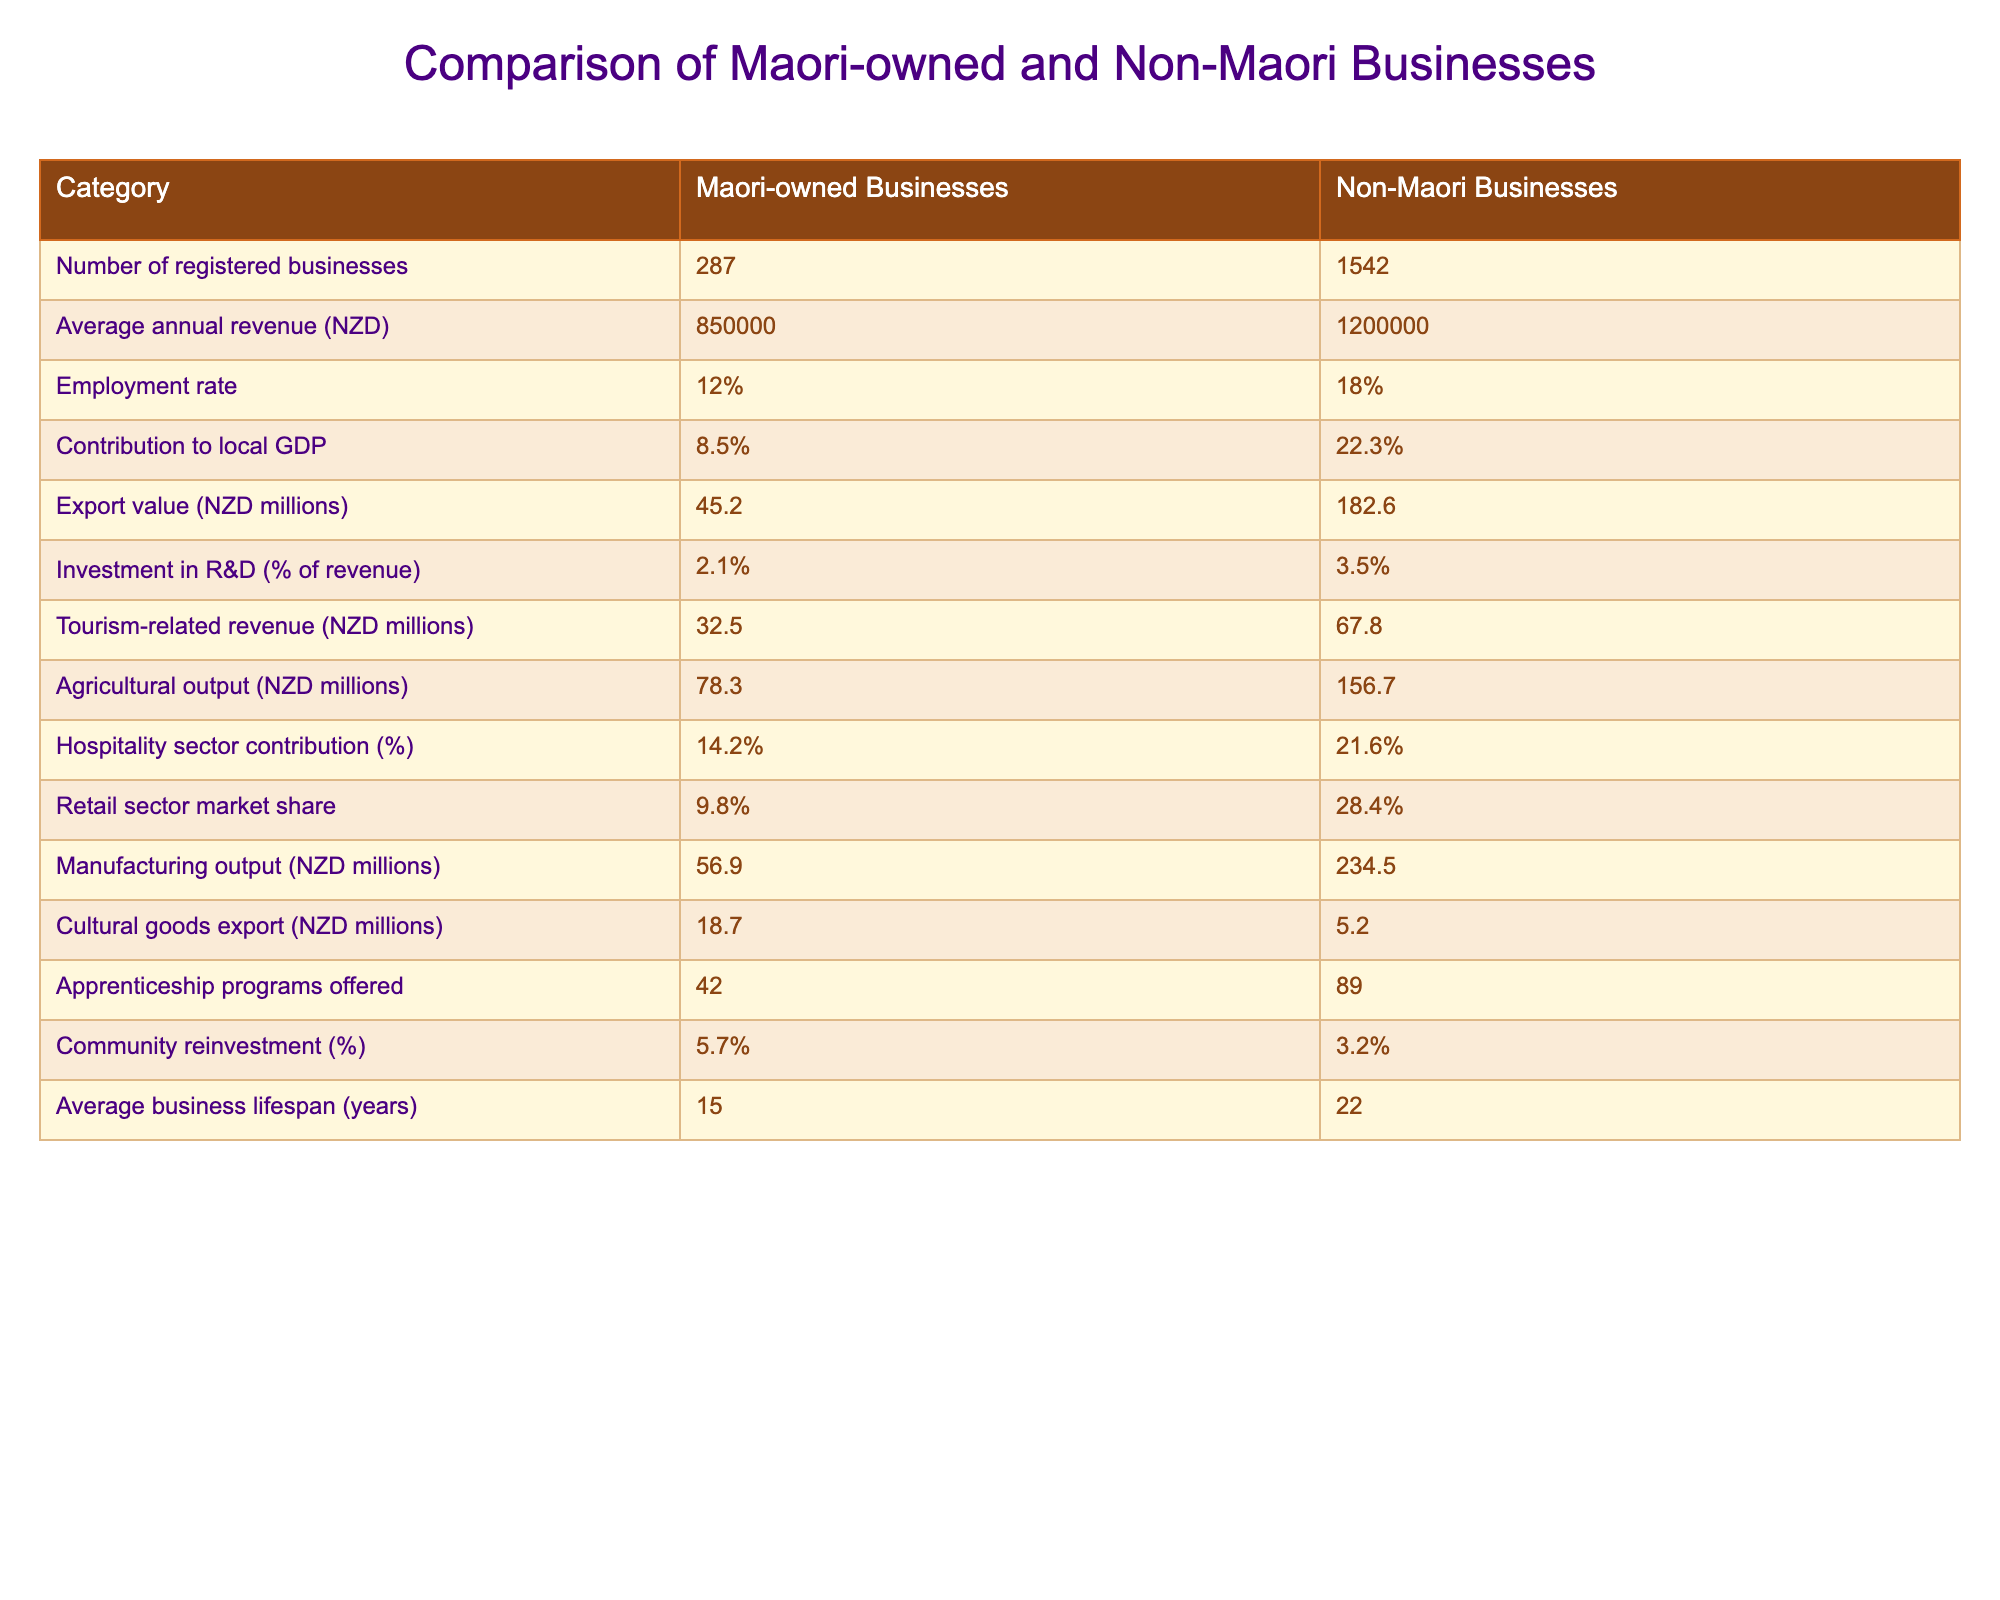What is the average annual revenue for Maori-owned businesses? According to the table, the average annual revenue for Maori-owned businesses is listed as 850000 NZD.
Answer: 850000 NZD What percentage of Maori-owned businesses contribute to the local GDP? The table shows that Maori-owned businesses contribute 8.5% to the local GDP.
Answer: 8.5% How much higher is the export value of non-Maori businesses compared to Maori-owned businesses? The export value for non-Maori businesses is 182.6 million NZD and for Maori-owned businesses, it is 45.2 million NZD. The difference is 182.6 - 45.2 = 137.4 million NZD.
Answer: 137.4 million NZD Do Maori-owned businesses have a higher community reinvestment percentage than non-Maori businesses? The community reinvestment percentage for Maori-owned businesses is 5.7% while for non-Maori businesses it is 3.2%. Since 5.7% is greater than 3.2%, the statement is true.
Answer: Yes What is the combined total of tourism-related revenue from both Maori and non-Maori businesses? The tourism-related revenue for Maori-owned businesses is 32.5 million NZD and for non-Maori businesses, it is 67.8 million NZD. The combined total is 32.5 + 67.8 = 100.3 million NZD.
Answer: 100.3 million NZD Which type of business has a longer average lifespan and what are the respective figures? From the table, non-Maori businesses have an average lifespan of 22 years while Maori-owned businesses have an average lifespan of 15 years. Thus, non-Maori businesses have a longer lifespan.
Answer: Non-Maori businesses, 22 years What is the difference in the number of registered businesses between Maori-owned and non-Maori businesses? The number of registered businesses for Maori-owned is 287 and for non-Maori is 1542. The difference is 1542 - 287 = 1255 registered businesses.
Answer: 1255 registered businesses Are Maori-owned businesses more involved in cultural goods export compared to non-Maori businesses? The table indicates that Maori-owned businesses export 18.7 million NZD in cultural goods while non-Maori businesses export 5.2 million NZD, showing that Maori-owned businesses are more involved in cultural goods export.
Answer: Yes 